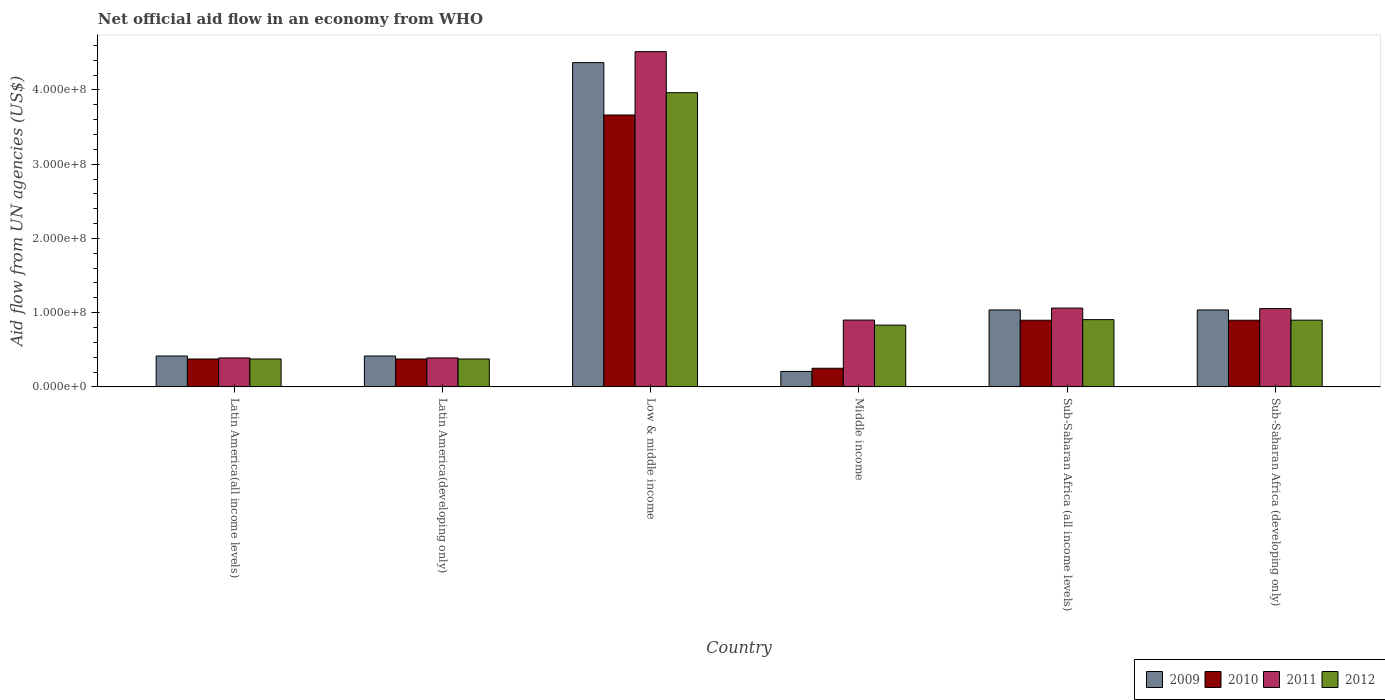Are the number of bars on each tick of the X-axis equal?
Your answer should be very brief. Yes. What is the label of the 4th group of bars from the left?
Offer a terse response. Middle income. What is the net official aid flow in 2012 in Latin America(developing only)?
Keep it short and to the point. 3.76e+07. Across all countries, what is the maximum net official aid flow in 2011?
Offer a terse response. 4.52e+08. Across all countries, what is the minimum net official aid flow in 2012?
Offer a terse response. 3.76e+07. In which country was the net official aid flow in 2010 minimum?
Provide a short and direct response. Middle income. What is the total net official aid flow in 2011 in the graph?
Offer a very short reply. 8.31e+08. What is the difference between the net official aid flow in 2009 in Low & middle income and that in Middle income?
Make the answer very short. 4.16e+08. What is the difference between the net official aid flow in 2010 in Low & middle income and the net official aid flow in 2011 in Sub-Saharan Africa (all income levels)?
Give a very brief answer. 2.60e+08. What is the average net official aid flow in 2009 per country?
Your answer should be compact. 1.25e+08. What is the difference between the net official aid flow of/in 2009 and net official aid flow of/in 2011 in Middle income?
Your response must be concise. -6.92e+07. In how many countries, is the net official aid flow in 2011 greater than 200000000 US$?
Offer a very short reply. 1. What is the ratio of the net official aid flow in 2010 in Latin America(developing only) to that in Sub-Saharan Africa (developing only)?
Provide a short and direct response. 0.42. Is the difference between the net official aid flow in 2009 in Latin America(developing only) and Low & middle income greater than the difference between the net official aid flow in 2011 in Latin America(developing only) and Low & middle income?
Offer a very short reply. Yes. What is the difference between the highest and the second highest net official aid flow in 2012?
Offer a terse response. 3.06e+08. What is the difference between the highest and the lowest net official aid flow in 2011?
Provide a succinct answer. 4.13e+08. Is the sum of the net official aid flow in 2012 in Low & middle income and Middle income greater than the maximum net official aid flow in 2010 across all countries?
Offer a terse response. Yes. Is it the case that in every country, the sum of the net official aid flow in 2011 and net official aid flow in 2012 is greater than the net official aid flow in 2009?
Give a very brief answer. Yes. How many bars are there?
Offer a terse response. 24. Are the values on the major ticks of Y-axis written in scientific E-notation?
Your answer should be very brief. Yes. Does the graph contain any zero values?
Keep it short and to the point. No. Where does the legend appear in the graph?
Keep it short and to the point. Bottom right. How many legend labels are there?
Provide a succinct answer. 4. What is the title of the graph?
Your answer should be compact. Net official aid flow in an economy from WHO. What is the label or title of the Y-axis?
Keep it short and to the point. Aid flow from UN agencies (US$). What is the Aid flow from UN agencies (US$) of 2009 in Latin America(all income levels)?
Keep it short and to the point. 4.16e+07. What is the Aid flow from UN agencies (US$) of 2010 in Latin America(all income levels)?
Offer a very short reply. 3.76e+07. What is the Aid flow from UN agencies (US$) of 2011 in Latin America(all income levels)?
Provide a short and direct response. 3.90e+07. What is the Aid flow from UN agencies (US$) of 2012 in Latin America(all income levels)?
Provide a succinct answer. 3.76e+07. What is the Aid flow from UN agencies (US$) in 2009 in Latin America(developing only)?
Offer a very short reply. 4.16e+07. What is the Aid flow from UN agencies (US$) in 2010 in Latin America(developing only)?
Provide a short and direct response. 3.76e+07. What is the Aid flow from UN agencies (US$) in 2011 in Latin America(developing only)?
Provide a succinct answer. 3.90e+07. What is the Aid flow from UN agencies (US$) of 2012 in Latin America(developing only)?
Provide a succinct answer. 3.76e+07. What is the Aid flow from UN agencies (US$) of 2009 in Low & middle income?
Make the answer very short. 4.37e+08. What is the Aid flow from UN agencies (US$) of 2010 in Low & middle income?
Provide a succinct answer. 3.66e+08. What is the Aid flow from UN agencies (US$) of 2011 in Low & middle income?
Offer a very short reply. 4.52e+08. What is the Aid flow from UN agencies (US$) of 2012 in Low & middle income?
Give a very brief answer. 3.96e+08. What is the Aid flow from UN agencies (US$) of 2009 in Middle income?
Your answer should be compact. 2.08e+07. What is the Aid flow from UN agencies (US$) in 2010 in Middle income?
Your answer should be compact. 2.51e+07. What is the Aid flow from UN agencies (US$) in 2011 in Middle income?
Offer a terse response. 9.00e+07. What is the Aid flow from UN agencies (US$) in 2012 in Middle income?
Keep it short and to the point. 8.32e+07. What is the Aid flow from UN agencies (US$) in 2009 in Sub-Saharan Africa (all income levels)?
Your answer should be very brief. 1.04e+08. What is the Aid flow from UN agencies (US$) of 2010 in Sub-Saharan Africa (all income levels)?
Provide a succinct answer. 8.98e+07. What is the Aid flow from UN agencies (US$) of 2011 in Sub-Saharan Africa (all income levels)?
Make the answer very short. 1.06e+08. What is the Aid flow from UN agencies (US$) of 2012 in Sub-Saharan Africa (all income levels)?
Provide a succinct answer. 9.06e+07. What is the Aid flow from UN agencies (US$) in 2009 in Sub-Saharan Africa (developing only)?
Offer a very short reply. 1.04e+08. What is the Aid flow from UN agencies (US$) of 2010 in Sub-Saharan Africa (developing only)?
Give a very brief answer. 8.98e+07. What is the Aid flow from UN agencies (US$) of 2011 in Sub-Saharan Africa (developing only)?
Your answer should be very brief. 1.05e+08. What is the Aid flow from UN agencies (US$) of 2012 in Sub-Saharan Africa (developing only)?
Keep it short and to the point. 8.98e+07. Across all countries, what is the maximum Aid flow from UN agencies (US$) in 2009?
Ensure brevity in your answer.  4.37e+08. Across all countries, what is the maximum Aid flow from UN agencies (US$) of 2010?
Your answer should be compact. 3.66e+08. Across all countries, what is the maximum Aid flow from UN agencies (US$) in 2011?
Keep it short and to the point. 4.52e+08. Across all countries, what is the maximum Aid flow from UN agencies (US$) in 2012?
Offer a very short reply. 3.96e+08. Across all countries, what is the minimum Aid flow from UN agencies (US$) of 2009?
Your response must be concise. 2.08e+07. Across all countries, what is the minimum Aid flow from UN agencies (US$) of 2010?
Offer a terse response. 2.51e+07. Across all countries, what is the minimum Aid flow from UN agencies (US$) in 2011?
Your answer should be very brief. 3.90e+07. Across all countries, what is the minimum Aid flow from UN agencies (US$) of 2012?
Keep it short and to the point. 3.76e+07. What is the total Aid flow from UN agencies (US$) in 2009 in the graph?
Give a very brief answer. 7.48e+08. What is the total Aid flow from UN agencies (US$) in 2010 in the graph?
Offer a very short reply. 6.46e+08. What is the total Aid flow from UN agencies (US$) in 2011 in the graph?
Give a very brief answer. 8.31e+08. What is the total Aid flow from UN agencies (US$) in 2012 in the graph?
Offer a terse response. 7.35e+08. What is the difference between the Aid flow from UN agencies (US$) in 2009 in Latin America(all income levels) and that in Latin America(developing only)?
Your answer should be compact. 0. What is the difference between the Aid flow from UN agencies (US$) of 2011 in Latin America(all income levels) and that in Latin America(developing only)?
Ensure brevity in your answer.  0. What is the difference between the Aid flow from UN agencies (US$) in 2009 in Latin America(all income levels) and that in Low & middle income?
Ensure brevity in your answer.  -3.95e+08. What is the difference between the Aid flow from UN agencies (US$) in 2010 in Latin America(all income levels) and that in Low & middle income?
Keep it short and to the point. -3.29e+08. What is the difference between the Aid flow from UN agencies (US$) in 2011 in Latin America(all income levels) and that in Low & middle income?
Give a very brief answer. -4.13e+08. What is the difference between the Aid flow from UN agencies (US$) of 2012 in Latin America(all income levels) and that in Low & middle income?
Give a very brief answer. -3.59e+08. What is the difference between the Aid flow from UN agencies (US$) in 2009 in Latin America(all income levels) and that in Middle income?
Offer a very short reply. 2.08e+07. What is the difference between the Aid flow from UN agencies (US$) of 2010 in Latin America(all income levels) and that in Middle income?
Ensure brevity in your answer.  1.25e+07. What is the difference between the Aid flow from UN agencies (US$) of 2011 in Latin America(all income levels) and that in Middle income?
Ensure brevity in your answer.  -5.10e+07. What is the difference between the Aid flow from UN agencies (US$) in 2012 in Latin America(all income levels) and that in Middle income?
Ensure brevity in your answer.  -4.56e+07. What is the difference between the Aid flow from UN agencies (US$) in 2009 in Latin America(all income levels) and that in Sub-Saharan Africa (all income levels)?
Offer a very short reply. -6.20e+07. What is the difference between the Aid flow from UN agencies (US$) of 2010 in Latin America(all income levels) and that in Sub-Saharan Africa (all income levels)?
Keep it short and to the point. -5.22e+07. What is the difference between the Aid flow from UN agencies (US$) of 2011 in Latin America(all income levels) and that in Sub-Saharan Africa (all income levels)?
Keep it short and to the point. -6.72e+07. What is the difference between the Aid flow from UN agencies (US$) in 2012 in Latin America(all income levels) and that in Sub-Saharan Africa (all income levels)?
Keep it short and to the point. -5.30e+07. What is the difference between the Aid flow from UN agencies (US$) of 2009 in Latin America(all income levels) and that in Sub-Saharan Africa (developing only)?
Provide a succinct answer. -6.20e+07. What is the difference between the Aid flow from UN agencies (US$) of 2010 in Latin America(all income levels) and that in Sub-Saharan Africa (developing only)?
Provide a short and direct response. -5.22e+07. What is the difference between the Aid flow from UN agencies (US$) in 2011 in Latin America(all income levels) and that in Sub-Saharan Africa (developing only)?
Your response must be concise. -6.65e+07. What is the difference between the Aid flow from UN agencies (US$) of 2012 in Latin America(all income levels) and that in Sub-Saharan Africa (developing only)?
Offer a very short reply. -5.23e+07. What is the difference between the Aid flow from UN agencies (US$) of 2009 in Latin America(developing only) and that in Low & middle income?
Keep it short and to the point. -3.95e+08. What is the difference between the Aid flow from UN agencies (US$) in 2010 in Latin America(developing only) and that in Low & middle income?
Your answer should be very brief. -3.29e+08. What is the difference between the Aid flow from UN agencies (US$) in 2011 in Latin America(developing only) and that in Low & middle income?
Your answer should be compact. -4.13e+08. What is the difference between the Aid flow from UN agencies (US$) in 2012 in Latin America(developing only) and that in Low & middle income?
Make the answer very short. -3.59e+08. What is the difference between the Aid flow from UN agencies (US$) in 2009 in Latin America(developing only) and that in Middle income?
Offer a terse response. 2.08e+07. What is the difference between the Aid flow from UN agencies (US$) in 2010 in Latin America(developing only) and that in Middle income?
Give a very brief answer. 1.25e+07. What is the difference between the Aid flow from UN agencies (US$) in 2011 in Latin America(developing only) and that in Middle income?
Your answer should be compact. -5.10e+07. What is the difference between the Aid flow from UN agencies (US$) in 2012 in Latin America(developing only) and that in Middle income?
Your response must be concise. -4.56e+07. What is the difference between the Aid flow from UN agencies (US$) in 2009 in Latin America(developing only) and that in Sub-Saharan Africa (all income levels)?
Your response must be concise. -6.20e+07. What is the difference between the Aid flow from UN agencies (US$) of 2010 in Latin America(developing only) and that in Sub-Saharan Africa (all income levels)?
Keep it short and to the point. -5.22e+07. What is the difference between the Aid flow from UN agencies (US$) of 2011 in Latin America(developing only) and that in Sub-Saharan Africa (all income levels)?
Make the answer very short. -6.72e+07. What is the difference between the Aid flow from UN agencies (US$) in 2012 in Latin America(developing only) and that in Sub-Saharan Africa (all income levels)?
Give a very brief answer. -5.30e+07. What is the difference between the Aid flow from UN agencies (US$) in 2009 in Latin America(developing only) and that in Sub-Saharan Africa (developing only)?
Keep it short and to the point. -6.20e+07. What is the difference between the Aid flow from UN agencies (US$) of 2010 in Latin America(developing only) and that in Sub-Saharan Africa (developing only)?
Offer a terse response. -5.22e+07. What is the difference between the Aid flow from UN agencies (US$) in 2011 in Latin America(developing only) and that in Sub-Saharan Africa (developing only)?
Your answer should be very brief. -6.65e+07. What is the difference between the Aid flow from UN agencies (US$) of 2012 in Latin America(developing only) and that in Sub-Saharan Africa (developing only)?
Make the answer very short. -5.23e+07. What is the difference between the Aid flow from UN agencies (US$) of 2009 in Low & middle income and that in Middle income?
Offer a very short reply. 4.16e+08. What is the difference between the Aid flow from UN agencies (US$) in 2010 in Low & middle income and that in Middle income?
Make the answer very short. 3.41e+08. What is the difference between the Aid flow from UN agencies (US$) in 2011 in Low & middle income and that in Middle income?
Provide a succinct answer. 3.62e+08. What is the difference between the Aid flow from UN agencies (US$) in 2012 in Low & middle income and that in Middle income?
Offer a terse response. 3.13e+08. What is the difference between the Aid flow from UN agencies (US$) in 2009 in Low & middle income and that in Sub-Saharan Africa (all income levels)?
Your response must be concise. 3.33e+08. What is the difference between the Aid flow from UN agencies (US$) in 2010 in Low & middle income and that in Sub-Saharan Africa (all income levels)?
Offer a very short reply. 2.76e+08. What is the difference between the Aid flow from UN agencies (US$) of 2011 in Low & middle income and that in Sub-Saharan Africa (all income levels)?
Ensure brevity in your answer.  3.45e+08. What is the difference between the Aid flow from UN agencies (US$) in 2012 in Low & middle income and that in Sub-Saharan Africa (all income levels)?
Your answer should be very brief. 3.06e+08. What is the difference between the Aid flow from UN agencies (US$) of 2009 in Low & middle income and that in Sub-Saharan Africa (developing only)?
Offer a very short reply. 3.33e+08. What is the difference between the Aid flow from UN agencies (US$) in 2010 in Low & middle income and that in Sub-Saharan Africa (developing only)?
Offer a very short reply. 2.76e+08. What is the difference between the Aid flow from UN agencies (US$) in 2011 in Low & middle income and that in Sub-Saharan Africa (developing only)?
Give a very brief answer. 3.46e+08. What is the difference between the Aid flow from UN agencies (US$) of 2012 in Low & middle income and that in Sub-Saharan Africa (developing only)?
Provide a short and direct response. 3.06e+08. What is the difference between the Aid flow from UN agencies (US$) in 2009 in Middle income and that in Sub-Saharan Africa (all income levels)?
Ensure brevity in your answer.  -8.28e+07. What is the difference between the Aid flow from UN agencies (US$) of 2010 in Middle income and that in Sub-Saharan Africa (all income levels)?
Provide a short and direct response. -6.47e+07. What is the difference between the Aid flow from UN agencies (US$) of 2011 in Middle income and that in Sub-Saharan Africa (all income levels)?
Keep it short and to the point. -1.62e+07. What is the difference between the Aid flow from UN agencies (US$) in 2012 in Middle income and that in Sub-Saharan Africa (all income levels)?
Offer a very short reply. -7.39e+06. What is the difference between the Aid flow from UN agencies (US$) in 2009 in Middle income and that in Sub-Saharan Africa (developing only)?
Ensure brevity in your answer.  -8.28e+07. What is the difference between the Aid flow from UN agencies (US$) in 2010 in Middle income and that in Sub-Saharan Africa (developing only)?
Ensure brevity in your answer.  -6.47e+07. What is the difference between the Aid flow from UN agencies (US$) in 2011 in Middle income and that in Sub-Saharan Africa (developing only)?
Provide a succinct answer. -1.55e+07. What is the difference between the Aid flow from UN agencies (US$) in 2012 in Middle income and that in Sub-Saharan Africa (developing only)?
Your answer should be compact. -6.67e+06. What is the difference between the Aid flow from UN agencies (US$) in 2011 in Sub-Saharan Africa (all income levels) and that in Sub-Saharan Africa (developing only)?
Your response must be concise. 6.70e+05. What is the difference between the Aid flow from UN agencies (US$) in 2012 in Sub-Saharan Africa (all income levels) and that in Sub-Saharan Africa (developing only)?
Your response must be concise. 7.20e+05. What is the difference between the Aid flow from UN agencies (US$) in 2009 in Latin America(all income levels) and the Aid flow from UN agencies (US$) in 2010 in Latin America(developing only)?
Your response must be concise. 4.01e+06. What is the difference between the Aid flow from UN agencies (US$) in 2009 in Latin America(all income levels) and the Aid flow from UN agencies (US$) in 2011 in Latin America(developing only)?
Make the answer very short. 2.59e+06. What is the difference between the Aid flow from UN agencies (US$) in 2009 in Latin America(all income levels) and the Aid flow from UN agencies (US$) in 2012 in Latin America(developing only)?
Provide a short and direct response. 3.99e+06. What is the difference between the Aid flow from UN agencies (US$) in 2010 in Latin America(all income levels) and the Aid flow from UN agencies (US$) in 2011 in Latin America(developing only)?
Provide a short and direct response. -1.42e+06. What is the difference between the Aid flow from UN agencies (US$) in 2011 in Latin America(all income levels) and the Aid flow from UN agencies (US$) in 2012 in Latin America(developing only)?
Provide a short and direct response. 1.40e+06. What is the difference between the Aid flow from UN agencies (US$) in 2009 in Latin America(all income levels) and the Aid flow from UN agencies (US$) in 2010 in Low & middle income?
Give a very brief answer. -3.25e+08. What is the difference between the Aid flow from UN agencies (US$) of 2009 in Latin America(all income levels) and the Aid flow from UN agencies (US$) of 2011 in Low & middle income?
Your response must be concise. -4.10e+08. What is the difference between the Aid flow from UN agencies (US$) of 2009 in Latin America(all income levels) and the Aid flow from UN agencies (US$) of 2012 in Low & middle income?
Give a very brief answer. -3.55e+08. What is the difference between the Aid flow from UN agencies (US$) in 2010 in Latin America(all income levels) and the Aid flow from UN agencies (US$) in 2011 in Low & middle income?
Your response must be concise. -4.14e+08. What is the difference between the Aid flow from UN agencies (US$) in 2010 in Latin America(all income levels) and the Aid flow from UN agencies (US$) in 2012 in Low & middle income?
Keep it short and to the point. -3.59e+08. What is the difference between the Aid flow from UN agencies (US$) in 2011 in Latin America(all income levels) and the Aid flow from UN agencies (US$) in 2012 in Low & middle income?
Provide a succinct answer. -3.57e+08. What is the difference between the Aid flow from UN agencies (US$) of 2009 in Latin America(all income levels) and the Aid flow from UN agencies (US$) of 2010 in Middle income?
Provide a short and direct response. 1.65e+07. What is the difference between the Aid flow from UN agencies (US$) of 2009 in Latin America(all income levels) and the Aid flow from UN agencies (US$) of 2011 in Middle income?
Your answer should be compact. -4.84e+07. What is the difference between the Aid flow from UN agencies (US$) in 2009 in Latin America(all income levels) and the Aid flow from UN agencies (US$) in 2012 in Middle income?
Your response must be concise. -4.16e+07. What is the difference between the Aid flow from UN agencies (US$) in 2010 in Latin America(all income levels) and the Aid flow from UN agencies (US$) in 2011 in Middle income?
Your answer should be very brief. -5.24e+07. What is the difference between the Aid flow from UN agencies (US$) of 2010 in Latin America(all income levels) and the Aid flow from UN agencies (US$) of 2012 in Middle income?
Make the answer very short. -4.56e+07. What is the difference between the Aid flow from UN agencies (US$) of 2011 in Latin America(all income levels) and the Aid flow from UN agencies (US$) of 2012 in Middle income?
Your response must be concise. -4.42e+07. What is the difference between the Aid flow from UN agencies (US$) in 2009 in Latin America(all income levels) and the Aid flow from UN agencies (US$) in 2010 in Sub-Saharan Africa (all income levels)?
Provide a succinct answer. -4.82e+07. What is the difference between the Aid flow from UN agencies (US$) in 2009 in Latin America(all income levels) and the Aid flow from UN agencies (US$) in 2011 in Sub-Saharan Africa (all income levels)?
Make the answer very short. -6.46e+07. What is the difference between the Aid flow from UN agencies (US$) in 2009 in Latin America(all income levels) and the Aid flow from UN agencies (US$) in 2012 in Sub-Saharan Africa (all income levels)?
Provide a succinct answer. -4.90e+07. What is the difference between the Aid flow from UN agencies (US$) of 2010 in Latin America(all income levels) and the Aid flow from UN agencies (US$) of 2011 in Sub-Saharan Africa (all income levels)?
Keep it short and to the point. -6.86e+07. What is the difference between the Aid flow from UN agencies (US$) in 2010 in Latin America(all income levels) and the Aid flow from UN agencies (US$) in 2012 in Sub-Saharan Africa (all income levels)?
Give a very brief answer. -5.30e+07. What is the difference between the Aid flow from UN agencies (US$) of 2011 in Latin America(all income levels) and the Aid flow from UN agencies (US$) of 2012 in Sub-Saharan Africa (all income levels)?
Keep it short and to the point. -5.16e+07. What is the difference between the Aid flow from UN agencies (US$) of 2009 in Latin America(all income levels) and the Aid flow from UN agencies (US$) of 2010 in Sub-Saharan Africa (developing only)?
Give a very brief answer. -4.82e+07. What is the difference between the Aid flow from UN agencies (US$) in 2009 in Latin America(all income levels) and the Aid flow from UN agencies (US$) in 2011 in Sub-Saharan Africa (developing only)?
Provide a short and direct response. -6.39e+07. What is the difference between the Aid flow from UN agencies (US$) in 2009 in Latin America(all income levels) and the Aid flow from UN agencies (US$) in 2012 in Sub-Saharan Africa (developing only)?
Ensure brevity in your answer.  -4.83e+07. What is the difference between the Aid flow from UN agencies (US$) of 2010 in Latin America(all income levels) and the Aid flow from UN agencies (US$) of 2011 in Sub-Saharan Africa (developing only)?
Your answer should be compact. -6.79e+07. What is the difference between the Aid flow from UN agencies (US$) of 2010 in Latin America(all income levels) and the Aid flow from UN agencies (US$) of 2012 in Sub-Saharan Africa (developing only)?
Your answer should be very brief. -5.23e+07. What is the difference between the Aid flow from UN agencies (US$) in 2011 in Latin America(all income levels) and the Aid flow from UN agencies (US$) in 2012 in Sub-Saharan Africa (developing only)?
Keep it short and to the point. -5.09e+07. What is the difference between the Aid flow from UN agencies (US$) of 2009 in Latin America(developing only) and the Aid flow from UN agencies (US$) of 2010 in Low & middle income?
Offer a very short reply. -3.25e+08. What is the difference between the Aid flow from UN agencies (US$) of 2009 in Latin America(developing only) and the Aid flow from UN agencies (US$) of 2011 in Low & middle income?
Your answer should be very brief. -4.10e+08. What is the difference between the Aid flow from UN agencies (US$) in 2009 in Latin America(developing only) and the Aid flow from UN agencies (US$) in 2012 in Low & middle income?
Offer a terse response. -3.55e+08. What is the difference between the Aid flow from UN agencies (US$) in 2010 in Latin America(developing only) and the Aid flow from UN agencies (US$) in 2011 in Low & middle income?
Provide a succinct answer. -4.14e+08. What is the difference between the Aid flow from UN agencies (US$) in 2010 in Latin America(developing only) and the Aid flow from UN agencies (US$) in 2012 in Low & middle income?
Your response must be concise. -3.59e+08. What is the difference between the Aid flow from UN agencies (US$) in 2011 in Latin America(developing only) and the Aid flow from UN agencies (US$) in 2012 in Low & middle income?
Give a very brief answer. -3.57e+08. What is the difference between the Aid flow from UN agencies (US$) in 2009 in Latin America(developing only) and the Aid flow from UN agencies (US$) in 2010 in Middle income?
Offer a terse response. 1.65e+07. What is the difference between the Aid flow from UN agencies (US$) of 2009 in Latin America(developing only) and the Aid flow from UN agencies (US$) of 2011 in Middle income?
Provide a short and direct response. -4.84e+07. What is the difference between the Aid flow from UN agencies (US$) in 2009 in Latin America(developing only) and the Aid flow from UN agencies (US$) in 2012 in Middle income?
Give a very brief answer. -4.16e+07. What is the difference between the Aid flow from UN agencies (US$) in 2010 in Latin America(developing only) and the Aid flow from UN agencies (US$) in 2011 in Middle income?
Make the answer very short. -5.24e+07. What is the difference between the Aid flow from UN agencies (US$) of 2010 in Latin America(developing only) and the Aid flow from UN agencies (US$) of 2012 in Middle income?
Your response must be concise. -4.56e+07. What is the difference between the Aid flow from UN agencies (US$) in 2011 in Latin America(developing only) and the Aid flow from UN agencies (US$) in 2012 in Middle income?
Your answer should be compact. -4.42e+07. What is the difference between the Aid flow from UN agencies (US$) of 2009 in Latin America(developing only) and the Aid flow from UN agencies (US$) of 2010 in Sub-Saharan Africa (all income levels)?
Offer a terse response. -4.82e+07. What is the difference between the Aid flow from UN agencies (US$) in 2009 in Latin America(developing only) and the Aid flow from UN agencies (US$) in 2011 in Sub-Saharan Africa (all income levels)?
Your answer should be compact. -6.46e+07. What is the difference between the Aid flow from UN agencies (US$) of 2009 in Latin America(developing only) and the Aid flow from UN agencies (US$) of 2012 in Sub-Saharan Africa (all income levels)?
Ensure brevity in your answer.  -4.90e+07. What is the difference between the Aid flow from UN agencies (US$) of 2010 in Latin America(developing only) and the Aid flow from UN agencies (US$) of 2011 in Sub-Saharan Africa (all income levels)?
Keep it short and to the point. -6.86e+07. What is the difference between the Aid flow from UN agencies (US$) in 2010 in Latin America(developing only) and the Aid flow from UN agencies (US$) in 2012 in Sub-Saharan Africa (all income levels)?
Make the answer very short. -5.30e+07. What is the difference between the Aid flow from UN agencies (US$) in 2011 in Latin America(developing only) and the Aid flow from UN agencies (US$) in 2012 in Sub-Saharan Africa (all income levels)?
Your response must be concise. -5.16e+07. What is the difference between the Aid flow from UN agencies (US$) in 2009 in Latin America(developing only) and the Aid flow from UN agencies (US$) in 2010 in Sub-Saharan Africa (developing only)?
Your answer should be compact. -4.82e+07. What is the difference between the Aid flow from UN agencies (US$) in 2009 in Latin America(developing only) and the Aid flow from UN agencies (US$) in 2011 in Sub-Saharan Africa (developing only)?
Keep it short and to the point. -6.39e+07. What is the difference between the Aid flow from UN agencies (US$) in 2009 in Latin America(developing only) and the Aid flow from UN agencies (US$) in 2012 in Sub-Saharan Africa (developing only)?
Your response must be concise. -4.83e+07. What is the difference between the Aid flow from UN agencies (US$) in 2010 in Latin America(developing only) and the Aid flow from UN agencies (US$) in 2011 in Sub-Saharan Africa (developing only)?
Provide a succinct answer. -6.79e+07. What is the difference between the Aid flow from UN agencies (US$) of 2010 in Latin America(developing only) and the Aid flow from UN agencies (US$) of 2012 in Sub-Saharan Africa (developing only)?
Keep it short and to the point. -5.23e+07. What is the difference between the Aid flow from UN agencies (US$) in 2011 in Latin America(developing only) and the Aid flow from UN agencies (US$) in 2012 in Sub-Saharan Africa (developing only)?
Offer a very short reply. -5.09e+07. What is the difference between the Aid flow from UN agencies (US$) in 2009 in Low & middle income and the Aid flow from UN agencies (US$) in 2010 in Middle income?
Provide a succinct answer. 4.12e+08. What is the difference between the Aid flow from UN agencies (US$) in 2009 in Low & middle income and the Aid flow from UN agencies (US$) in 2011 in Middle income?
Offer a terse response. 3.47e+08. What is the difference between the Aid flow from UN agencies (US$) of 2009 in Low & middle income and the Aid flow from UN agencies (US$) of 2012 in Middle income?
Your answer should be very brief. 3.54e+08. What is the difference between the Aid flow from UN agencies (US$) in 2010 in Low & middle income and the Aid flow from UN agencies (US$) in 2011 in Middle income?
Offer a terse response. 2.76e+08. What is the difference between the Aid flow from UN agencies (US$) of 2010 in Low & middle income and the Aid flow from UN agencies (US$) of 2012 in Middle income?
Your answer should be compact. 2.83e+08. What is the difference between the Aid flow from UN agencies (US$) of 2011 in Low & middle income and the Aid flow from UN agencies (US$) of 2012 in Middle income?
Keep it short and to the point. 3.68e+08. What is the difference between the Aid flow from UN agencies (US$) of 2009 in Low & middle income and the Aid flow from UN agencies (US$) of 2010 in Sub-Saharan Africa (all income levels)?
Provide a succinct answer. 3.47e+08. What is the difference between the Aid flow from UN agencies (US$) of 2009 in Low & middle income and the Aid flow from UN agencies (US$) of 2011 in Sub-Saharan Africa (all income levels)?
Ensure brevity in your answer.  3.31e+08. What is the difference between the Aid flow from UN agencies (US$) of 2009 in Low & middle income and the Aid flow from UN agencies (US$) of 2012 in Sub-Saharan Africa (all income levels)?
Offer a very short reply. 3.46e+08. What is the difference between the Aid flow from UN agencies (US$) of 2010 in Low & middle income and the Aid flow from UN agencies (US$) of 2011 in Sub-Saharan Africa (all income levels)?
Your answer should be very brief. 2.60e+08. What is the difference between the Aid flow from UN agencies (US$) of 2010 in Low & middle income and the Aid flow from UN agencies (US$) of 2012 in Sub-Saharan Africa (all income levels)?
Offer a terse response. 2.76e+08. What is the difference between the Aid flow from UN agencies (US$) in 2011 in Low & middle income and the Aid flow from UN agencies (US$) in 2012 in Sub-Saharan Africa (all income levels)?
Your answer should be compact. 3.61e+08. What is the difference between the Aid flow from UN agencies (US$) of 2009 in Low & middle income and the Aid flow from UN agencies (US$) of 2010 in Sub-Saharan Africa (developing only)?
Offer a terse response. 3.47e+08. What is the difference between the Aid flow from UN agencies (US$) of 2009 in Low & middle income and the Aid flow from UN agencies (US$) of 2011 in Sub-Saharan Africa (developing only)?
Make the answer very short. 3.31e+08. What is the difference between the Aid flow from UN agencies (US$) of 2009 in Low & middle income and the Aid flow from UN agencies (US$) of 2012 in Sub-Saharan Africa (developing only)?
Ensure brevity in your answer.  3.47e+08. What is the difference between the Aid flow from UN agencies (US$) of 2010 in Low & middle income and the Aid flow from UN agencies (US$) of 2011 in Sub-Saharan Africa (developing only)?
Offer a terse response. 2.61e+08. What is the difference between the Aid flow from UN agencies (US$) of 2010 in Low & middle income and the Aid flow from UN agencies (US$) of 2012 in Sub-Saharan Africa (developing only)?
Provide a succinct answer. 2.76e+08. What is the difference between the Aid flow from UN agencies (US$) of 2011 in Low & middle income and the Aid flow from UN agencies (US$) of 2012 in Sub-Saharan Africa (developing only)?
Make the answer very short. 3.62e+08. What is the difference between the Aid flow from UN agencies (US$) of 2009 in Middle income and the Aid flow from UN agencies (US$) of 2010 in Sub-Saharan Africa (all income levels)?
Your response must be concise. -6.90e+07. What is the difference between the Aid flow from UN agencies (US$) in 2009 in Middle income and the Aid flow from UN agencies (US$) in 2011 in Sub-Saharan Africa (all income levels)?
Make the answer very short. -8.54e+07. What is the difference between the Aid flow from UN agencies (US$) of 2009 in Middle income and the Aid flow from UN agencies (US$) of 2012 in Sub-Saharan Africa (all income levels)?
Give a very brief answer. -6.98e+07. What is the difference between the Aid flow from UN agencies (US$) of 2010 in Middle income and the Aid flow from UN agencies (US$) of 2011 in Sub-Saharan Africa (all income levels)?
Provide a short and direct response. -8.11e+07. What is the difference between the Aid flow from UN agencies (US$) of 2010 in Middle income and the Aid flow from UN agencies (US$) of 2012 in Sub-Saharan Africa (all income levels)?
Your answer should be compact. -6.55e+07. What is the difference between the Aid flow from UN agencies (US$) of 2011 in Middle income and the Aid flow from UN agencies (US$) of 2012 in Sub-Saharan Africa (all income levels)?
Your answer should be compact. -5.90e+05. What is the difference between the Aid flow from UN agencies (US$) of 2009 in Middle income and the Aid flow from UN agencies (US$) of 2010 in Sub-Saharan Africa (developing only)?
Make the answer very short. -6.90e+07. What is the difference between the Aid flow from UN agencies (US$) of 2009 in Middle income and the Aid flow from UN agencies (US$) of 2011 in Sub-Saharan Africa (developing only)?
Keep it short and to the point. -8.47e+07. What is the difference between the Aid flow from UN agencies (US$) in 2009 in Middle income and the Aid flow from UN agencies (US$) in 2012 in Sub-Saharan Africa (developing only)?
Ensure brevity in your answer.  -6.90e+07. What is the difference between the Aid flow from UN agencies (US$) of 2010 in Middle income and the Aid flow from UN agencies (US$) of 2011 in Sub-Saharan Africa (developing only)?
Give a very brief answer. -8.04e+07. What is the difference between the Aid flow from UN agencies (US$) of 2010 in Middle income and the Aid flow from UN agencies (US$) of 2012 in Sub-Saharan Africa (developing only)?
Offer a terse response. -6.48e+07. What is the difference between the Aid flow from UN agencies (US$) in 2011 in Middle income and the Aid flow from UN agencies (US$) in 2012 in Sub-Saharan Africa (developing only)?
Provide a short and direct response. 1.30e+05. What is the difference between the Aid flow from UN agencies (US$) of 2009 in Sub-Saharan Africa (all income levels) and the Aid flow from UN agencies (US$) of 2010 in Sub-Saharan Africa (developing only)?
Your response must be concise. 1.39e+07. What is the difference between the Aid flow from UN agencies (US$) of 2009 in Sub-Saharan Africa (all income levels) and the Aid flow from UN agencies (US$) of 2011 in Sub-Saharan Africa (developing only)?
Your response must be concise. -1.86e+06. What is the difference between the Aid flow from UN agencies (US$) of 2009 in Sub-Saharan Africa (all income levels) and the Aid flow from UN agencies (US$) of 2012 in Sub-Saharan Africa (developing only)?
Give a very brief answer. 1.38e+07. What is the difference between the Aid flow from UN agencies (US$) in 2010 in Sub-Saharan Africa (all income levels) and the Aid flow from UN agencies (US$) in 2011 in Sub-Saharan Africa (developing only)?
Offer a very short reply. -1.57e+07. What is the difference between the Aid flow from UN agencies (US$) in 2011 in Sub-Saharan Africa (all income levels) and the Aid flow from UN agencies (US$) in 2012 in Sub-Saharan Africa (developing only)?
Give a very brief answer. 1.63e+07. What is the average Aid flow from UN agencies (US$) in 2009 per country?
Make the answer very short. 1.25e+08. What is the average Aid flow from UN agencies (US$) in 2010 per country?
Keep it short and to the point. 1.08e+08. What is the average Aid flow from UN agencies (US$) of 2011 per country?
Make the answer very short. 1.39e+08. What is the average Aid flow from UN agencies (US$) of 2012 per country?
Offer a very short reply. 1.23e+08. What is the difference between the Aid flow from UN agencies (US$) in 2009 and Aid flow from UN agencies (US$) in 2010 in Latin America(all income levels)?
Your answer should be very brief. 4.01e+06. What is the difference between the Aid flow from UN agencies (US$) of 2009 and Aid flow from UN agencies (US$) of 2011 in Latin America(all income levels)?
Ensure brevity in your answer.  2.59e+06. What is the difference between the Aid flow from UN agencies (US$) in 2009 and Aid flow from UN agencies (US$) in 2012 in Latin America(all income levels)?
Your answer should be very brief. 3.99e+06. What is the difference between the Aid flow from UN agencies (US$) of 2010 and Aid flow from UN agencies (US$) of 2011 in Latin America(all income levels)?
Provide a succinct answer. -1.42e+06. What is the difference between the Aid flow from UN agencies (US$) in 2010 and Aid flow from UN agencies (US$) in 2012 in Latin America(all income levels)?
Offer a very short reply. -2.00e+04. What is the difference between the Aid flow from UN agencies (US$) of 2011 and Aid flow from UN agencies (US$) of 2012 in Latin America(all income levels)?
Make the answer very short. 1.40e+06. What is the difference between the Aid flow from UN agencies (US$) in 2009 and Aid flow from UN agencies (US$) in 2010 in Latin America(developing only)?
Offer a terse response. 4.01e+06. What is the difference between the Aid flow from UN agencies (US$) in 2009 and Aid flow from UN agencies (US$) in 2011 in Latin America(developing only)?
Provide a short and direct response. 2.59e+06. What is the difference between the Aid flow from UN agencies (US$) of 2009 and Aid flow from UN agencies (US$) of 2012 in Latin America(developing only)?
Your answer should be very brief. 3.99e+06. What is the difference between the Aid flow from UN agencies (US$) in 2010 and Aid flow from UN agencies (US$) in 2011 in Latin America(developing only)?
Your response must be concise. -1.42e+06. What is the difference between the Aid flow from UN agencies (US$) in 2011 and Aid flow from UN agencies (US$) in 2012 in Latin America(developing only)?
Give a very brief answer. 1.40e+06. What is the difference between the Aid flow from UN agencies (US$) of 2009 and Aid flow from UN agencies (US$) of 2010 in Low & middle income?
Provide a short and direct response. 7.06e+07. What is the difference between the Aid flow from UN agencies (US$) of 2009 and Aid flow from UN agencies (US$) of 2011 in Low & middle income?
Your response must be concise. -1.48e+07. What is the difference between the Aid flow from UN agencies (US$) in 2009 and Aid flow from UN agencies (US$) in 2012 in Low & middle income?
Your answer should be very brief. 4.05e+07. What is the difference between the Aid flow from UN agencies (US$) of 2010 and Aid flow from UN agencies (US$) of 2011 in Low & middle income?
Your answer should be compact. -8.54e+07. What is the difference between the Aid flow from UN agencies (US$) of 2010 and Aid flow from UN agencies (US$) of 2012 in Low & middle income?
Ensure brevity in your answer.  -3.00e+07. What is the difference between the Aid flow from UN agencies (US$) of 2011 and Aid flow from UN agencies (US$) of 2012 in Low & middle income?
Provide a succinct answer. 5.53e+07. What is the difference between the Aid flow from UN agencies (US$) of 2009 and Aid flow from UN agencies (US$) of 2010 in Middle income?
Your response must be concise. -4.27e+06. What is the difference between the Aid flow from UN agencies (US$) in 2009 and Aid flow from UN agencies (US$) in 2011 in Middle income?
Provide a short and direct response. -6.92e+07. What is the difference between the Aid flow from UN agencies (US$) in 2009 and Aid flow from UN agencies (US$) in 2012 in Middle income?
Your answer should be compact. -6.24e+07. What is the difference between the Aid flow from UN agencies (US$) of 2010 and Aid flow from UN agencies (US$) of 2011 in Middle income?
Your answer should be compact. -6.49e+07. What is the difference between the Aid flow from UN agencies (US$) of 2010 and Aid flow from UN agencies (US$) of 2012 in Middle income?
Your answer should be very brief. -5.81e+07. What is the difference between the Aid flow from UN agencies (US$) of 2011 and Aid flow from UN agencies (US$) of 2012 in Middle income?
Keep it short and to the point. 6.80e+06. What is the difference between the Aid flow from UN agencies (US$) of 2009 and Aid flow from UN agencies (US$) of 2010 in Sub-Saharan Africa (all income levels)?
Provide a short and direct response. 1.39e+07. What is the difference between the Aid flow from UN agencies (US$) of 2009 and Aid flow from UN agencies (US$) of 2011 in Sub-Saharan Africa (all income levels)?
Your answer should be very brief. -2.53e+06. What is the difference between the Aid flow from UN agencies (US$) of 2009 and Aid flow from UN agencies (US$) of 2012 in Sub-Saharan Africa (all income levels)?
Give a very brief answer. 1.30e+07. What is the difference between the Aid flow from UN agencies (US$) of 2010 and Aid flow from UN agencies (US$) of 2011 in Sub-Saharan Africa (all income levels)?
Keep it short and to the point. -1.64e+07. What is the difference between the Aid flow from UN agencies (US$) in 2010 and Aid flow from UN agencies (US$) in 2012 in Sub-Saharan Africa (all income levels)?
Keep it short and to the point. -8.10e+05. What is the difference between the Aid flow from UN agencies (US$) of 2011 and Aid flow from UN agencies (US$) of 2012 in Sub-Saharan Africa (all income levels)?
Ensure brevity in your answer.  1.56e+07. What is the difference between the Aid flow from UN agencies (US$) in 2009 and Aid flow from UN agencies (US$) in 2010 in Sub-Saharan Africa (developing only)?
Offer a terse response. 1.39e+07. What is the difference between the Aid flow from UN agencies (US$) in 2009 and Aid flow from UN agencies (US$) in 2011 in Sub-Saharan Africa (developing only)?
Your answer should be very brief. -1.86e+06. What is the difference between the Aid flow from UN agencies (US$) in 2009 and Aid flow from UN agencies (US$) in 2012 in Sub-Saharan Africa (developing only)?
Keep it short and to the point. 1.38e+07. What is the difference between the Aid flow from UN agencies (US$) of 2010 and Aid flow from UN agencies (US$) of 2011 in Sub-Saharan Africa (developing only)?
Make the answer very short. -1.57e+07. What is the difference between the Aid flow from UN agencies (US$) in 2010 and Aid flow from UN agencies (US$) in 2012 in Sub-Saharan Africa (developing only)?
Offer a terse response. -9.00e+04. What is the difference between the Aid flow from UN agencies (US$) in 2011 and Aid flow from UN agencies (US$) in 2012 in Sub-Saharan Africa (developing only)?
Your response must be concise. 1.56e+07. What is the ratio of the Aid flow from UN agencies (US$) in 2009 in Latin America(all income levels) to that in Latin America(developing only)?
Your answer should be compact. 1. What is the ratio of the Aid flow from UN agencies (US$) in 2009 in Latin America(all income levels) to that in Low & middle income?
Give a very brief answer. 0.1. What is the ratio of the Aid flow from UN agencies (US$) in 2010 in Latin America(all income levels) to that in Low & middle income?
Provide a succinct answer. 0.1. What is the ratio of the Aid flow from UN agencies (US$) in 2011 in Latin America(all income levels) to that in Low & middle income?
Ensure brevity in your answer.  0.09. What is the ratio of the Aid flow from UN agencies (US$) of 2012 in Latin America(all income levels) to that in Low & middle income?
Your response must be concise. 0.09. What is the ratio of the Aid flow from UN agencies (US$) in 2009 in Latin America(all income levels) to that in Middle income?
Offer a terse response. 2. What is the ratio of the Aid flow from UN agencies (US$) in 2010 in Latin America(all income levels) to that in Middle income?
Ensure brevity in your answer.  1.5. What is the ratio of the Aid flow from UN agencies (US$) of 2011 in Latin America(all income levels) to that in Middle income?
Provide a short and direct response. 0.43. What is the ratio of the Aid flow from UN agencies (US$) of 2012 in Latin America(all income levels) to that in Middle income?
Ensure brevity in your answer.  0.45. What is the ratio of the Aid flow from UN agencies (US$) of 2009 in Latin America(all income levels) to that in Sub-Saharan Africa (all income levels)?
Keep it short and to the point. 0.4. What is the ratio of the Aid flow from UN agencies (US$) in 2010 in Latin America(all income levels) to that in Sub-Saharan Africa (all income levels)?
Make the answer very short. 0.42. What is the ratio of the Aid flow from UN agencies (US$) of 2011 in Latin America(all income levels) to that in Sub-Saharan Africa (all income levels)?
Make the answer very short. 0.37. What is the ratio of the Aid flow from UN agencies (US$) in 2012 in Latin America(all income levels) to that in Sub-Saharan Africa (all income levels)?
Your response must be concise. 0.41. What is the ratio of the Aid flow from UN agencies (US$) in 2009 in Latin America(all income levels) to that in Sub-Saharan Africa (developing only)?
Provide a short and direct response. 0.4. What is the ratio of the Aid flow from UN agencies (US$) of 2010 in Latin America(all income levels) to that in Sub-Saharan Africa (developing only)?
Provide a succinct answer. 0.42. What is the ratio of the Aid flow from UN agencies (US$) in 2011 in Latin America(all income levels) to that in Sub-Saharan Africa (developing only)?
Offer a very short reply. 0.37. What is the ratio of the Aid flow from UN agencies (US$) of 2012 in Latin America(all income levels) to that in Sub-Saharan Africa (developing only)?
Offer a terse response. 0.42. What is the ratio of the Aid flow from UN agencies (US$) of 2009 in Latin America(developing only) to that in Low & middle income?
Ensure brevity in your answer.  0.1. What is the ratio of the Aid flow from UN agencies (US$) in 2010 in Latin America(developing only) to that in Low & middle income?
Provide a succinct answer. 0.1. What is the ratio of the Aid flow from UN agencies (US$) in 2011 in Latin America(developing only) to that in Low & middle income?
Ensure brevity in your answer.  0.09. What is the ratio of the Aid flow from UN agencies (US$) of 2012 in Latin America(developing only) to that in Low & middle income?
Your answer should be compact. 0.09. What is the ratio of the Aid flow from UN agencies (US$) in 2009 in Latin America(developing only) to that in Middle income?
Offer a terse response. 2. What is the ratio of the Aid flow from UN agencies (US$) of 2010 in Latin America(developing only) to that in Middle income?
Provide a succinct answer. 1.5. What is the ratio of the Aid flow from UN agencies (US$) of 2011 in Latin America(developing only) to that in Middle income?
Your response must be concise. 0.43. What is the ratio of the Aid flow from UN agencies (US$) of 2012 in Latin America(developing only) to that in Middle income?
Your response must be concise. 0.45. What is the ratio of the Aid flow from UN agencies (US$) in 2009 in Latin America(developing only) to that in Sub-Saharan Africa (all income levels)?
Offer a terse response. 0.4. What is the ratio of the Aid flow from UN agencies (US$) of 2010 in Latin America(developing only) to that in Sub-Saharan Africa (all income levels)?
Make the answer very short. 0.42. What is the ratio of the Aid flow from UN agencies (US$) of 2011 in Latin America(developing only) to that in Sub-Saharan Africa (all income levels)?
Provide a short and direct response. 0.37. What is the ratio of the Aid flow from UN agencies (US$) in 2012 in Latin America(developing only) to that in Sub-Saharan Africa (all income levels)?
Your answer should be compact. 0.41. What is the ratio of the Aid flow from UN agencies (US$) in 2009 in Latin America(developing only) to that in Sub-Saharan Africa (developing only)?
Your answer should be compact. 0.4. What is the ratio of the Aid flow from UN agencies (US$) in 2010 in Latin America(developing only) to that in Sub-Saharan Africa (developing only)?
Ensure brevity in your answer.  0.42. What is the ratio of the Aid flow from UN agencies (US$) of 2011 in Latin America(developing only) to that in Sub-Saharan Africa (developing only)?
Provide a short and direct response. 0.37. What is the ratio of the Aid flow from UN agencies (US$) of 2012 in Latin America(developing only) to that in Sub-Saharan Africa (developing only)?
Ensure brevity in your answer.  0.42. What is the ratio of the Aid flow from UN agencies (US$) in 2009 in Low & middle income to that in Middle income?
Ensure brevity in your answer.  21. What is the ratio of the Aid flow from UN agencies (US$) of 2010 in Low & middle income to that in Middle income?
Ensure brevity in your answer.  14.61. What is the ratio of the Aid flow from UN agencies (US$) in 2011 in Low & middle income to that in Middle income?
Provide a succinct answer. 5.02. What is the ratio of the Aid flow from UN agencies (US$) of 2012 in Low & middle income to that in Middle income?
Offer a very short reply. 4.76. What is the ratio of the Aid flow from UN agencies (US$) in 2009 in Low & middle income to that in Sub-Saharan Africa (all income levels)?
Keep it short and to the point. 4.22. What is the ratio of the Aid flow from UN agencies (US$) in 2010 in Low & middle income to that in Sub-Saharan Africa (all income levels)?
Make the answer very short. 4.08. What is the ratio of the Aid flow from UN agencies (US$) in 2011 in Low & middle income to that in Sub-Saharan Africa (all income levels)?
Provide a succinct answer. 4.25. What is the ratio of the Aid flow from UN agencies (US$) in 2012 in Low & middle income to that in Sub-Saharan Africa (all income levels)?
Your answer should be very brief. 4.38. What is the ratio of the Aid flow from UN agencies (US$) in 2009 in Low & middle income to that in Sub-Saharan Africa (developing only)?
Make the answer very short. 4.22. What is the ratio of the Aid flow from UN agencies (US$) in 2010 in Low & middle income to that in Sub-Saharan Africa (developing only)?
Make the answer very short. 4.08. What is the ratio of the Aid flow from UN agencies (US$) in 2011 in Low & middle income to that in Sub-Saharan Africa (developing only)?
Provide a succinct answer. 4.28. What is the ratio of the Aid flow from UN agencies (US$) of 2012 in Low & middle income to that in Sub-Saharan Africa (developing only)?
Your answer should be very brief. 4.41. What is the ratio of the Aid flow from UN agencies (US$) of 2009 in Middle income to that in Sub-Saharan Africa (all income levels)?
Give a very brief answer. 0.2. What is the ratio of the Aid flow from UN agencies (US$) of 2010 in Middle income to that in Sub-Saharan Africa (all income levels)?
Your answer should be very brief. 0.28. What is the ratio of the Aid flow from UN agencies (US$) in 2011 in Middle income to that in Sub-Saharan Africa (all income levels)?
Provide a short and direct response. 0.85. What is the ratio of the Aid flow from UN agencies (US$) in 2012 in Middle income to that in Sub-Saharan Africa (all income levels)?
Your answer should be very brief. 0.92. What is the ratio of the Aid flow from UN agencies (US$) of 2009 in Middle income to that in Sub-Saharan Africa (developing only)?
Give a very brief answer. 0.2. What is the ratio of the Aid flow from UN agencies (US$) in 2010 in Middle income to that in Sub-Saharan Africa (developing only)?
Give a very brief answer. 0.28. What is the ratio of the Aid flow from UN agencies (US$) of 2011 in Middle income to that in Sub-Saharan Africa (developing only)?
Ensure brevity in your answer.  0.85. What is the ratio of the Aid flow from UN agencies (US$) in 2012 in Middle income to that in Sub-Saharan Africa (developing only)?
Provide a short and direct response. 0.93. What is the ratio of the Aid flow from UN agencies (US$) of 2009 in Sub-Saharan Africa (all income levels) to that in Sub-Saharan Africa (developing only)?
Keep it short and to the point. 1. What is the ratio of the Aid flow from UN agencies (US$) in 2011 in Sub-Saharan Africa (all income levels) to that in Sub-Saharan Africa (developing only)?
Provide a short and direct response. 1.01. What is the difference between the highest and the second highest Aid flow from UN agencies (US$) in 2009?
Offer a terse response. 3.33e+08. What is the difference between the highest and the second highest Aid flow from UN agencies (US$) in 2010?
Your answer should be very brief. 2.76e+08. What is the difference between the highest and the second highest Aid flow from UN agencies (US$) of 2011?
Your answer should be very brief. 3.45e+08. What is the difference between the highest and the second highest Aid flow from UN agencies (US$) in 2012?
Provide a short and direct response. 3.06e+08. What is the difference between the highest and the lowest Aid flow from UN agencies (US$) in 2009?
Offer a very short reply. 4.16e+08. What is the difference between the highest and the lowest Aid flow from UN agencies (US$) in 2010?
Your answer should be very brief. 3.41e+08. What is the difference between the highest and the lowest Aid flow from UN agencies (US$) in 2011?
Offer a very short reply. 4.13e+08. What is the difference between the highest and the lowest Aid flow from UN agencies (US$) in 2012?
Keep it short and to the point. 3.59e+08. 